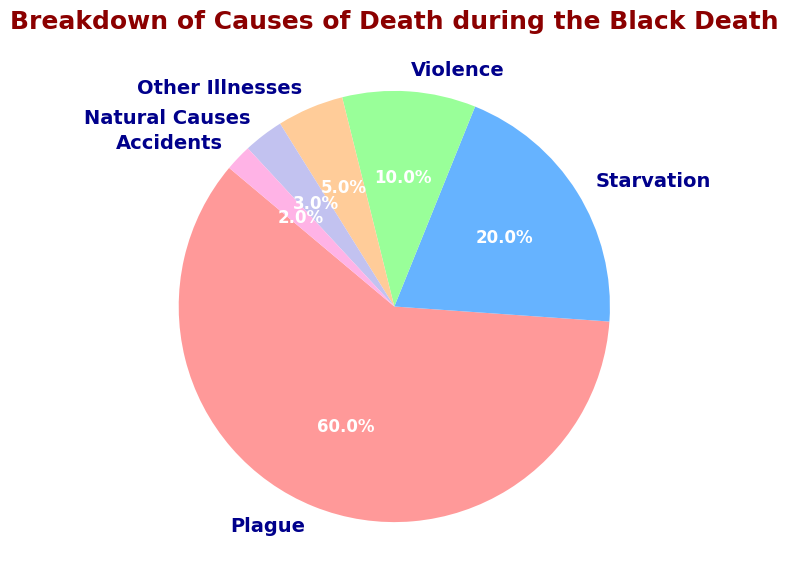What percentage of deaths were due to causes other than the plague? To find the percentage of deaths due to causes other than the plague, sum the percentages of starvation, violence, other illnesses, natural causes, and accidents which are 20+10+5+3+2.
Answer: 40% Which category had the second-highest percentage of deaths? The category with the highest percentage of deaths is the plague at 60%. The second-highest is starvation at 20%.
Answer: Starvation How do the combined percentages of violence and other illnesses compare to the percentage from natural causes? Add the percentages of violence (10%) and other illnesses (5%) to get 15%. Natural causes account for 3%. 15% is greater than 3%.
Answer: Violence and other illnesses combined are greater than natural causes What category has the smallest slice in the pie chart and what is its percentage? Identify the category with the smallest percentage. That category is accidents with 2%.
Answer: Accidents, 2% What is the difference between the percentage of deaths caused by plague and the combined percentages of deaths from violence and other illnesses? The percentage from the plague is 60%. The combined percentage for violence and other illnesses is 10% + 5% = 15%. The difference is 60% - 15% = 45%.
Answer: 45% Are there more deaths from starvation or from violence plus other illnesses? The death percentage from starvation is 20%. The combined percentage from violence and other illnesses is 10% + 5% = 15%. Starvation has a higher percentage.
Answer: Starvation What is the visual color representation of the category with the highest percentage of deaths? The pie chart uses color coding to represent different categories. The highest percentage of deaths comes from the plague. According to the color scheme provided, plague is represented by the color red.
Answer: Red What is the combined percentage of deaths from other illnesses and natural causes, and is it higher or lower than starvation? The percentage from other illnesses is 5% and natural causes is 3%, adding up to 5% + 3% = 8%. Starvation accounts for 20%, which is higher than 8%.
Answer: 8%, lower If you combine the percentages of natural causes and accidents, what percentage of total deaths does that represent? Natural causes account for 3% and accidents for 2%. Combined, they account for 3% + 2% = 5% of total deaths.
Answer: 5% What logical reasoning can you use to determine that plague had the most significant impact on death rates during the Black Death period? The pie chart shows that the plague accounts for 60% of the deaths, which is a majority compared to other causes. This indicates its significant impact.
Answer: The plague had the most significant impact 